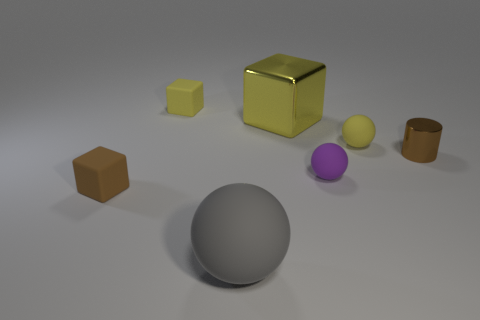Add 1 metallic cylinders. How many objects exist? 8 Subtract all blocks. How many objects are left? 4 Subtract 0 purple cylinders. How many objects are left? 7 Subtract all tiny gray metal cylinders. Subtract all balls. How many objects are left? 4 Add 6 purple balls. How many purple balls are left? 7 Add 4 yellow objects. How many yellow objects exist? 7 